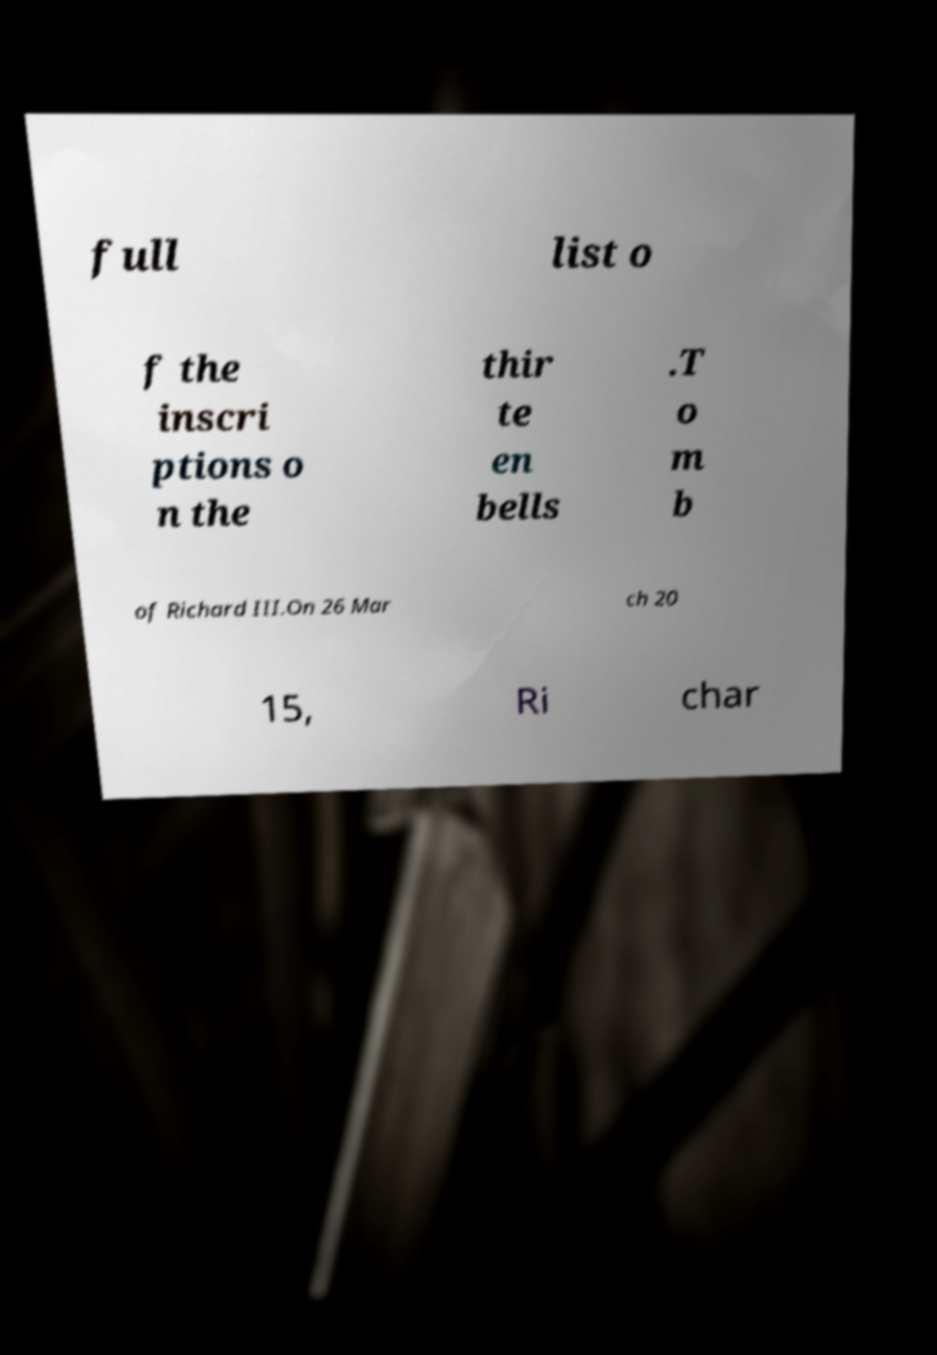Can you read and provide the text displayed in the image?This photo seems to have some interesting text. Can you extract and type it out for me? full list o f the inscri ptions o n the thir te en bells .T o m b of Richard III.On 26 Mar ch 20 15, Ri char 